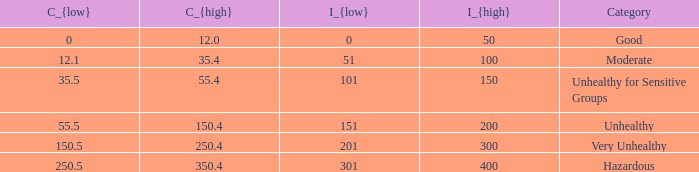How many different C_{high} values are there for the good category? 1.0. 